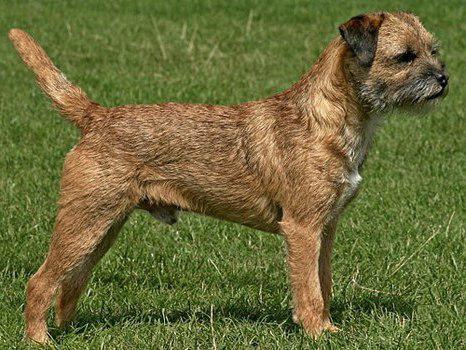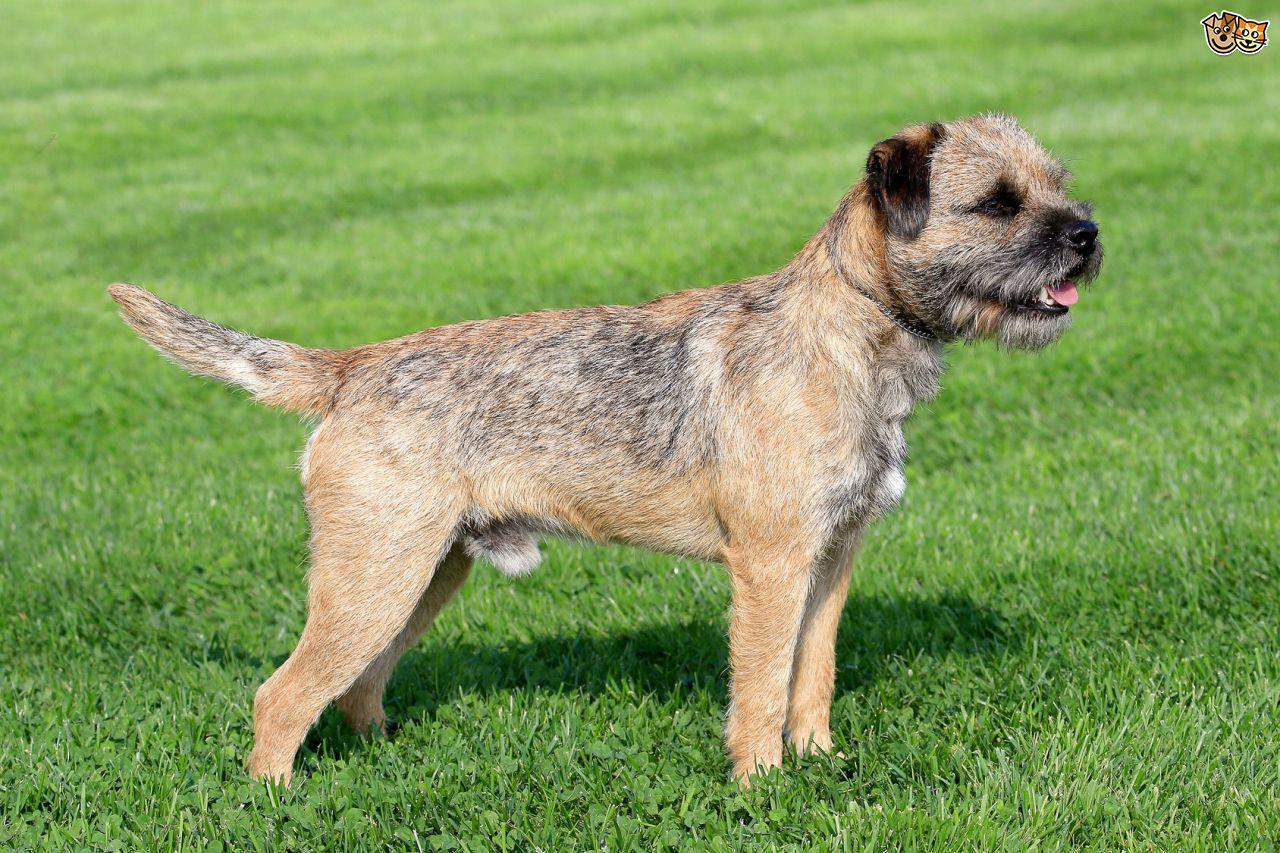The first image is the image on the left, the second image is the image on the right. Analyze the images presented: Is the assertion "The dogs in the right and left images have the same pose and face the same direction." valid? Answer yes or no. Yes. The first image is the image on the left, the second image is the image on the right. For the images shown, is this caption "Both dogs are standing in profile and facing the same direction." true? Answer yes or no. Yes. 